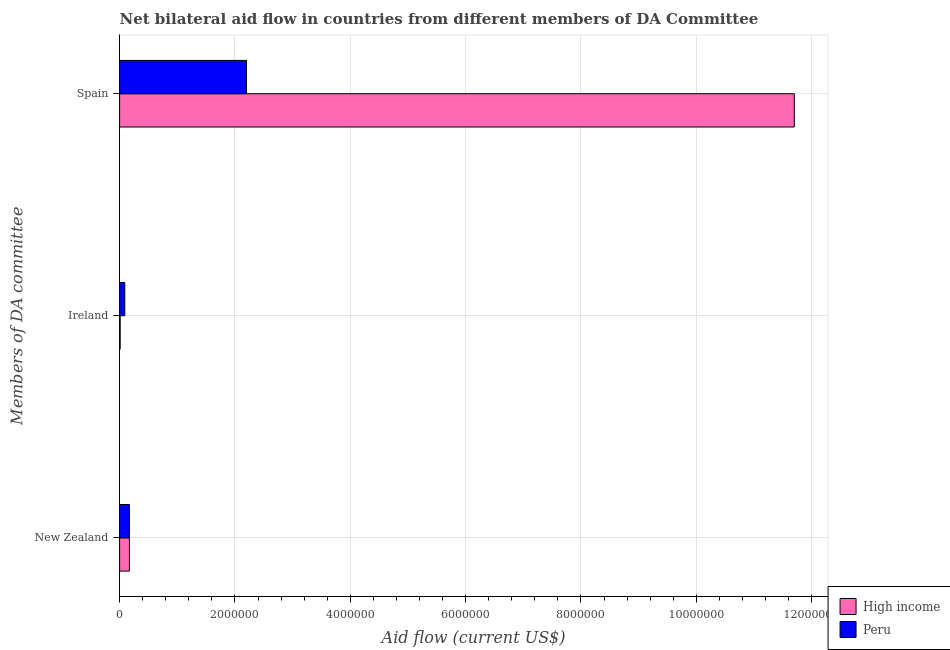How many different coloured bars are there?
Give a very brief answer. 2. How many groups of bars are there?
Offer a very short reply. 3. Are the number of bars per tick equal to the number of legend labels?
Offer a very short reply. Yes. How many bars are there on the 3rd tick from the top?
Offer a terse response. 2. What is the label of the 3rd group of bars from the top?
Offer a terse response. New Zealand. What is the amount of aid provided by spain in High income?
Provide a succinct answer. 1.17e+07. Across all countries, what is the maximum amount of aid provided by new zealand?
Your response must be concise. 1.70e+05. Across all countries, what is the minimum amount of aid provided by spain?
Give a very brief answer. 2.20e+06. What is the total amount of aid provided by spain in the graph?
Your response must be concise. 1.39e+07. What is the difference between the amount of aid provided by spain in High income and that in Peru?
Keep it short and to the point. 9.50e+06. What is the difference between the amount of aid provided by ireland in High income and the amount of aid provided by spain in Peru?
Offer a terse response. -2.19e+06. What is the average amount of aid provided by spain per country?
Give a very brief answer. 6.95e+06. What is the difference between the amount of aid provided by new zealand and amount of aid provided by spain in Peru?
Offer a terse response. -2.03e+06. What is the ratio of the amount of aid provided by new zealand in Peru to that in High income?
Your response must be concise. 1. Is the difference between the amount of aid provided by spain in High income and Peru greater than the difference between the amount of aid provided by new zealand in High income and Peru?
Keep it short and to the point. Yes. What is the difference between the highest and the lowest amount of aid provided by ireland?
Ensure brevity in your answer.  8.00e+04. Is it the case that in every country, the sum of the amount of aid provided by new zealand and amount of aid provided by ireland is greater than the amount of aid provided by spain?
Keep it short and to the point. No. How many bars are there?
Provide a short and direct response. 6. Are all the bars in the graph horizontal?
Provide a short and direct response. Yes. What is the difference between two consecutive major ticks on the X-axis?
Your answer should be very brief. 2.00e+06. Are the values on the major ticks of X-axis written in scientific E-notation?
Offer a terse response. No. How many legend labels are there?
Make the answer very short. 2. What is the title of the graph?
Make the answer very short. Net bilateral aid flow in countries from different members of DA Committee. Does "Barbados" appear as one of the legend labels in the graph?
Make the answer very short. No. What is the label or title of the X-axis?
Make the answer very short. Aid flow (current US$). What is the label or title of the Y-axis?
Offer a very short reply. Members of DA committee. What is the Aid flow (current US$) in Peru in New Zealand?
Offer a terse response. 1.70e+05. What is the Aid flow (current US$) of High income in Ireland?
Offer a very short reply. 10000. What is the Aid flow (current US$) of Peru in Ireland?
Keep it short and to the point. 9.00e+04. What is the Aid flow (current US$) in High income in Spain?
Your response must be concise. 1.17e+07. What is the Aid flow (current US$) of Peru in Spain?
Make the answer very short. 2.20e+06. Across all Members of DA committee, what is the maximum Aid flow (current US$) in High income?
Your answer should be very brief. 1.17e+07. Across all Members of DA committee, what is the maximum Aid flow (current US$) in Peru?
Your answer should be compact. 2.20e+06. Across all Members of DA committee, what is the minimum Aid flow (current US$) of High income?
Ensure brevity in your answer.  10000. Across all Members of DA committee, what is the minimum Aid flow (current US$) in Peru?
Your answer should be compact. 9.00e+04. What is the total Aid flow (current US$) in High income in the graph?
Provide a succinct answer. 1.19e+07. What is the total Aid flow (current US$) in Peru in the graph?
Give a very brief answer. 2.46e+06. What is the difference between the Aid flow (current US$) in High income in New Zealand and that in Ireland?
Provide a succinct answer. 1.60e+05. What is the difference between the Aid flow (current US$) in High income in New Zealand and that in Spain?
Ensure brevity in your answer.  -1.15e+07. What is the difference between the Aid flow (current US$) in Peru in New Zealand and that in Spain?
Provide a succinct answer. -2.03e+06. What is the difference between the Aid flow (current US$) in High income in Ireland and that in Spain?
Your answer should be very brief. -1.17e+07. What is the difference between the Aid flow (current US$) of Peru in Ireland and that in Spain?
Offer a terse response. -2.11e+06. What is the difference between the Aid flow (current US$) in High income in New Zealand and the Aid flow (current US$) in Peru in Ireland?
Provide a succinct answer. 8.00e+04. What is the difference between the Aid flow (current US$) in High income in New Zealand and the Aid flow (current US$) in Peru in Spain?
Keep it short and to the point. -2.03e+06. What is the difference between the Aid flow (current US$) of High income in Ireland and the Aid flow (current US$) of Peru in Spain?
Ensure brevity in your answer.  -2.19e+06. What is the average Aid flow (current US$) of High income per Members of DA committee?
Keep it short and to the point. 3.96e+06. What is the average Aid flow (current US$) in Peru per Members of DA committee?
Make the answer very short. 8.20e+05. What is the difference between the Aid flow (current US$) of High income and Aid flow (current US$) of Peru in Spain?
Offer a very short reply. 9.50e+06. What is the ratio of the Aid flow (current US$) of High income in New Zealand to that in Ireland?
Your answer should be very brief. 17. What is the ratio of the Aid flow (current US$) of Peru in New Zealand to that in Ireland?
Provide a short and direct response. 1.89. What is the ratio of the Aid flow (current US$) of High income in New Zealand to that in Spain?
Make the answer very short. 0.01. What is the ratio of the Aid flow (current US$) in Peru in New Zealand to that in Spain?
Keep it short and to the point. 0.08. What is the ratio of the Aid flow (current US$) of High income in Ireland to that in Spain?
Keep it short and to the point. 0. What is the ratio of the Aid flow (current US$) of Peru in Ireland to that in Spain?
Provide a succinct answer. 0.04. What is the difference between the highest and the second highest Aid flow (current US$) in High income?
Provide a short and direct response. 1.15e+07. What is the difference between the highest and the second highest Aid flow (current US$) of Peru?
Your answer should be compact. 2.03e+06. What is the difference between the highest and the lowest Aid flow (current US$) of High income?
Your response must be concise. 1.17e+07. What is the difference between the highest and the lowest Aid flow (current US$) of Peru?
Your answer should be very brief. 2.11e+06. 